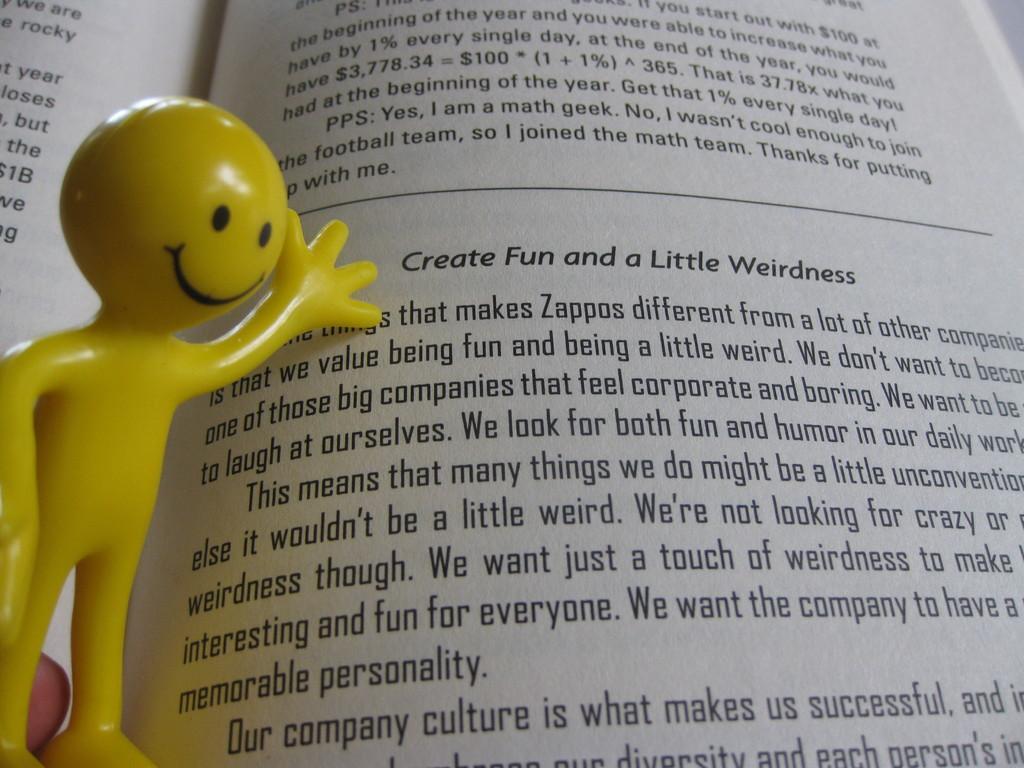Please provide a concise description of this image. This image consists of a book. In the front, we can see a text. On the left, there is a doll in yellow color. 